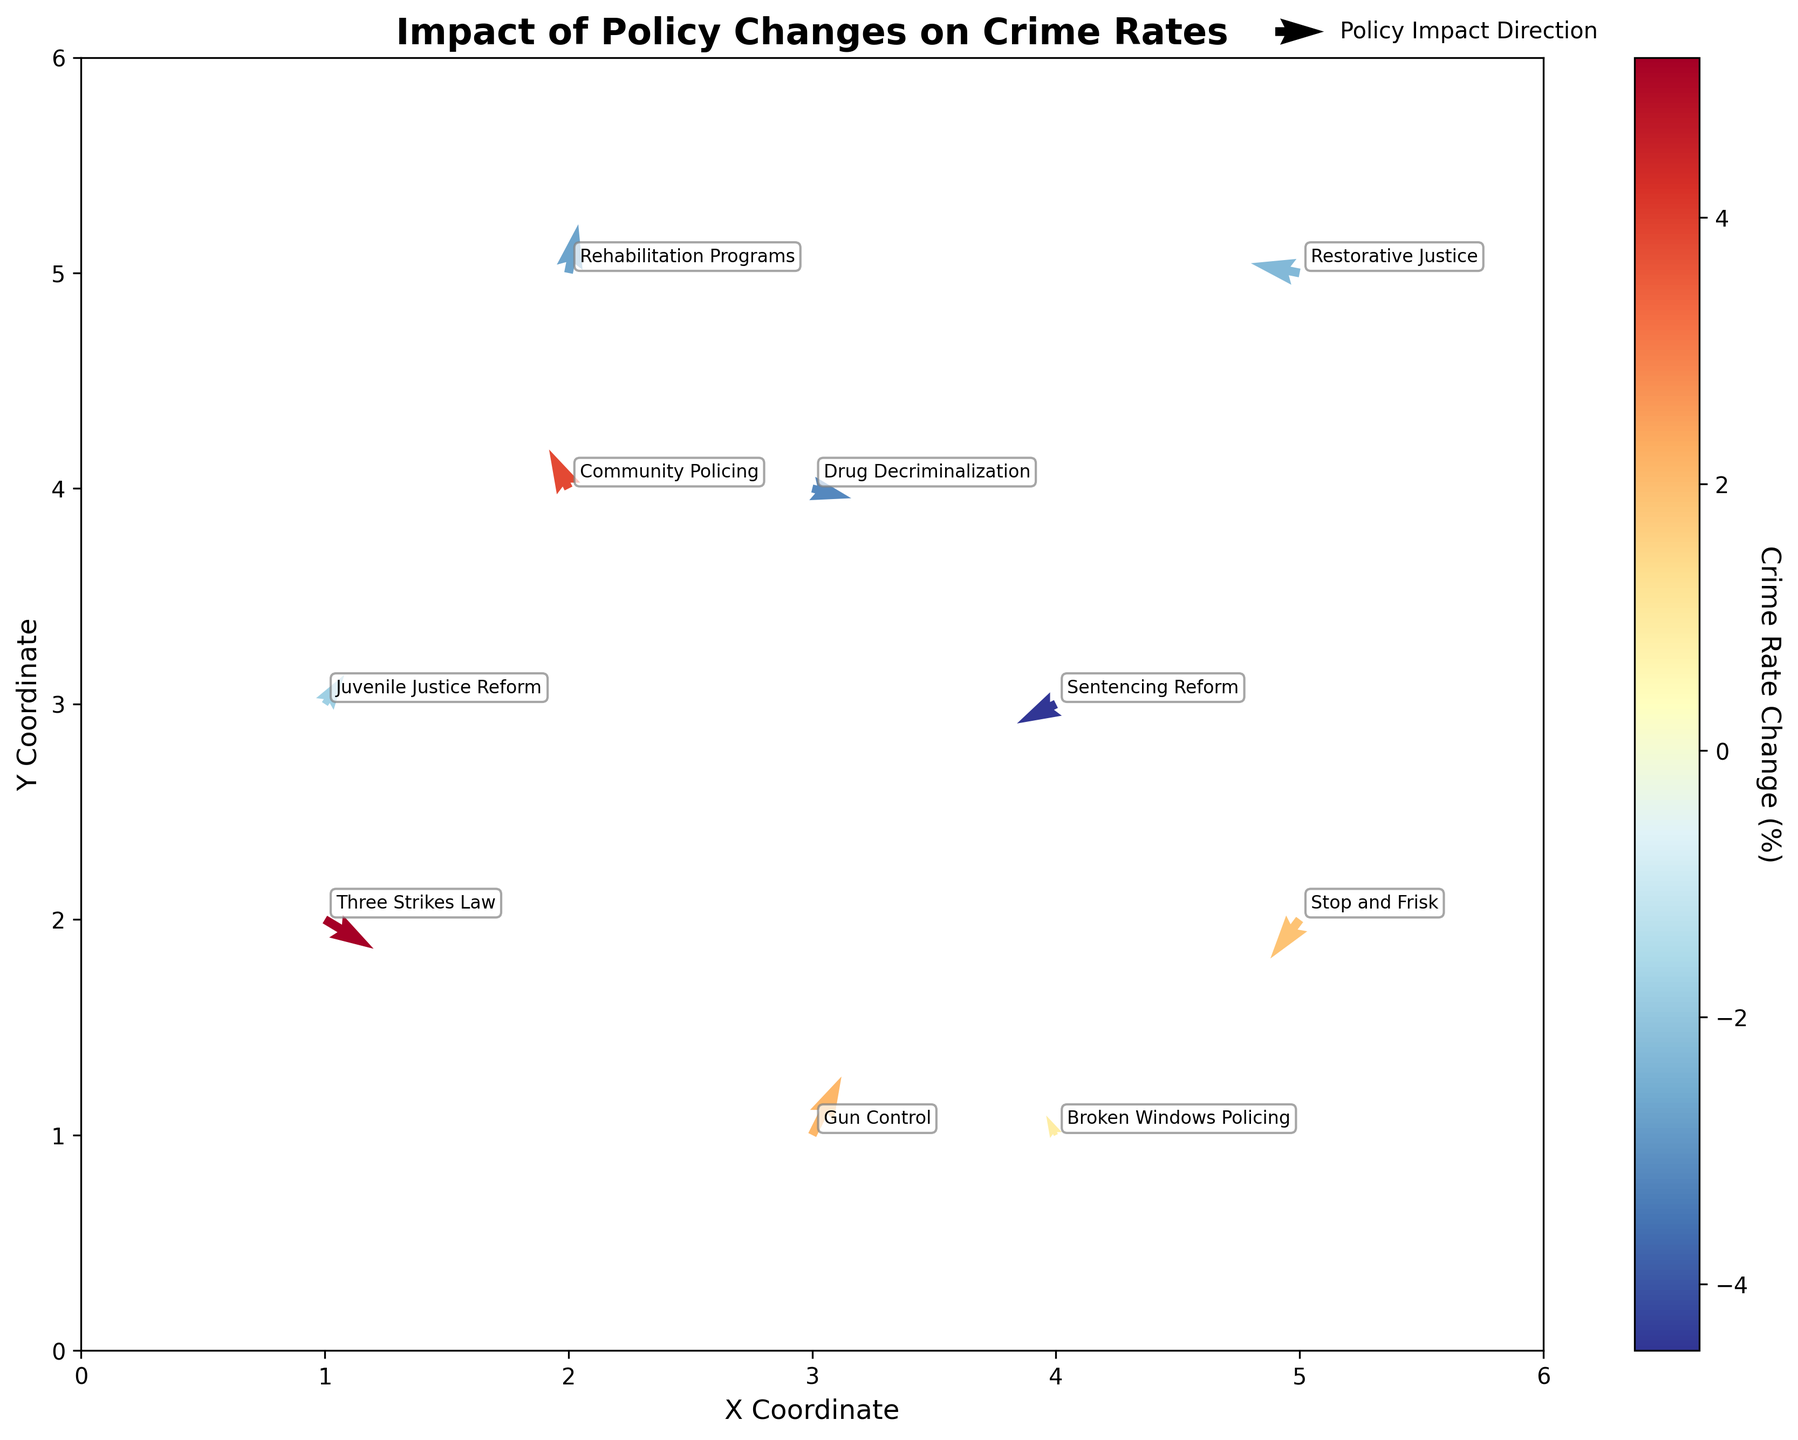How many policy changes are represented in the plot? Count the total number of unique policy labels annotated in the plot. There are 10 policy changes labeled in the figure.
Answer: 10 What is the direction of the arrow for the "Sentencing Reform" policy? Find the arrow that corresponds to the "Sentencing Reform" label. The arrow points left and downward, indicating the direction of its impact.
Answer: Left and downward Which policy had the greatest positive change in crime rates? Compare the color intensity and direction of the arrows. The "Three Strikes Law" has the highest positive change in crime rates at 5.2%.
Answer: Three Strikes Law What is the color associated with the "Community Policing" policy arrow? Note the color mapped to the arrow for "Community Policing". It should be in the central region of the color bar, indicating a moderate crime rate change. The color is a light yellow.
Answer: Light yellow What is the average crime rate change among all policies? Sum all the crime rate changes and divide by the number of policies: (5.2 + 3.8 + 2.1 - 4.5 - 2.7 + 1.9 - 3.2 - 1.8 + 0.9 - 2.3) / 10 = -0.06
Answer: -0.06 Which policy's impact direction is upward and to the right? Find the arrows that point upward and to the right. The "Gun Control" policy's arrow meets this criteria.
Answer: Gun Control How many policies show a decrease in crime rates? Count the number of policies with negative crime rate changes. There are 6 policies (Sentencing Reform, Rehabilitation Programs, Drug Decriminalization, Juvenile Justice Reform, Restorative Justice).
Answer: 6 Which two policies have arrows pointing horizontally? Identify the policies with arrows that have no vertical (v) component. "Broken Windows Policing" and "Community Policing" have arrows pointing horizontally.
Answer: Broken Windows Policing, Community Policing What is the total sum of the crime rate changes for policies that cause a negative change? Sum the crime rate changes for policies with negative values: (-4.5 - 2.7 - 3.2 - 1.8 - 2.3) = -14.5
Answer: -14.5 